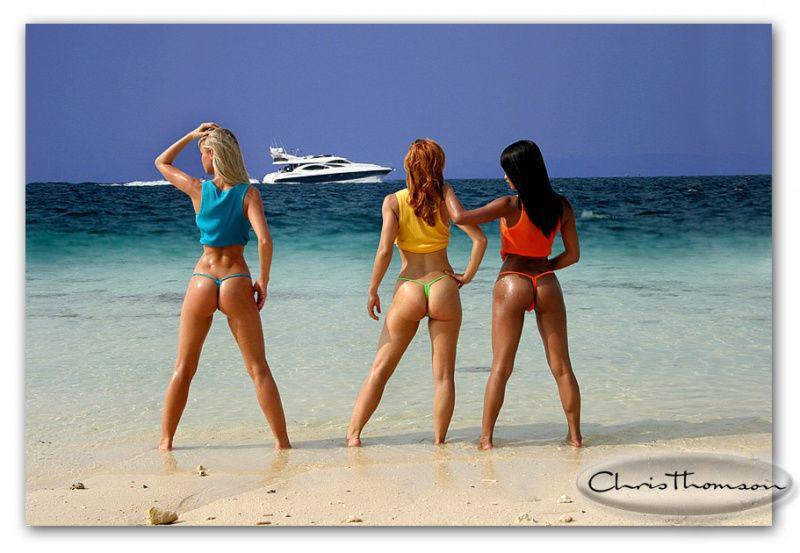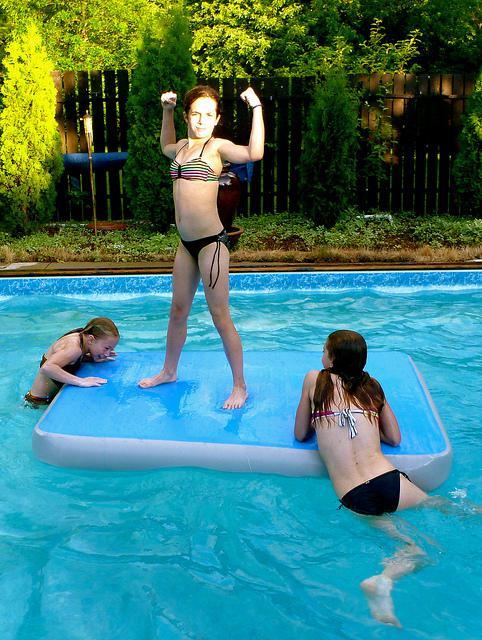The first image is the image on the left, the second image is the image on the right. Analyze the images presented: Is the assertion "An image shows three bikini models facing the ocean, with backs to the camera." valid? Answer yes or no. Yes. The first image is the image on the left, the second image is the image on the right. Examine the images to the left and right. Is the description "Three women are in swimsuits near the water." accurate? Answer yes or no. Yes. 